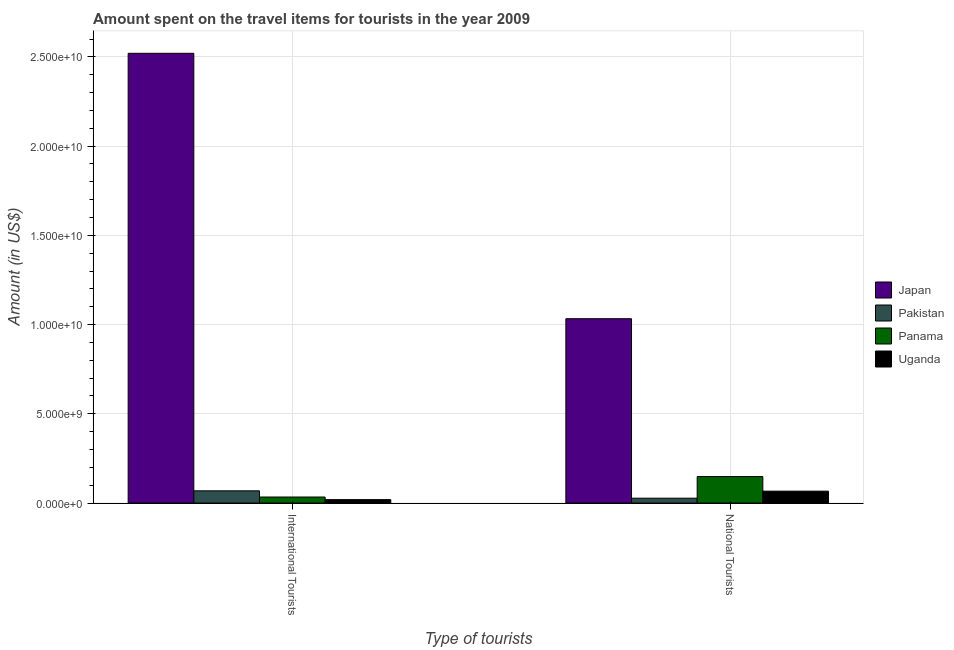How many different coloured bars are there?
Keep it short and to the point. 4. How many groups of bars are there?
Make the answer very short. 2. How many bars are there on the 1st tick from the right?
Your answer should be very brief. 4. What is the label of the 2nd group of bars from the left?
Your answer should be very brief. National Tourists. What is the amount spent on travel items of international tourists in Japan?
Ensure brevity in your answer.  2.52e+1. Across all countries, what is the maximum amount spent on travel items of international tourists?
Your answer should be very brief. 2.52e+1. Across all countries, what is the minimum amount spent on travel items of international tourists?
Provide a short and direct response. 1.92e+08. In which country was the amount spent on travel items of international tourists maximum?
Your answer should be compact. Japan. In which country was the amount spent on travel items of international tourists minimum?
Offer a very short reply. Uganda. What is the total amount spent on travel items of national tourists in the graph?
Ensure brevity in your answer.  1.28e+1. What is the difference between the amount spent on travel items of national tourists in Japan and that in Uganda?
Offer a very short reply. 9.66e+09. What is the difference between the amount spent on travel items of international tourists in Japan and the amount spent on travel items of national tourists in Pakistan?
Your answer should be compact. 2.49e+1. What is the average amount spent on travel items of national tourists per country?
Provide a succinct answer. 3.19e+09. What is the difference between the amount spent on travel items of national tourists and amount spent on travel items of international tourists in Uganda?
Your answer should be compact. 4.75e+08. What is the ratio of the amount spent on travel items of international tourists in Uganda to that in Japan?
Provide a succinct answer. 0.01. Is the amount spent on travel items of international tourists in Panama less than that in Pakistan?
Keep it short and to the point. Yes. In how many countries, is the amount spent on travel items of national tourists greater than the average amount spent on travel items of national tourists taken over all countries?
Your response must be concise. 1. What does the 2nd bar from the left in National Tourists represents?
Your answer should be very brief. Pakistan. What does the 4th bar from the right in National Tourists represents?
Ensure brevity in your answer.  Japan. Are all the bars in the graph horizontal?
Ensure brevity in your answer.  No. Does the graph contain grids?
Your answer should be compact. Yes. Where does the legend appear in the graph?
Give a very brief answer. Center right. How are the legend labels stacked?
Ensure brevity in your answer.  Vertical. What is the title of the graph?
Provide a short and direct response. Amount spent on the travel items for tourists in the year 2009. Does "Lao PDR" appear as one of the legend labels in the graph?
Your response must be concise. No. What is the label or title of the X-axis?
Ensure brevity in your answer.  Type of tourists. What is the Amount (in US$) in Japan in International Tourists?
Keep it short and to the point. 2.52e+1. What is the Amount (in US$) of Pakistan in International Tourists?
Ensure brevity in your answer.  6.85e+08. What is the Amount (in US$) in Panama in International Tourists?
Your answer should be compact. 3.38e+08. What is the Amount (in US$) in Uganda in International Tourists?
Give a very brief answer. 1.92e+08. What is the Amount (in US$) in Japan in National Tourists?
Your answer should be very brief. 1.03e+1. What is the Amount (in US$) in Pakistan in National Tourists?
Make the answer very short. 2.72e+08. What is the Amount (in US$) in Panama in National Tourists?
Give a very brief answer. 1.48e+09. What is the Amount (in US$) in Uganda in National Tourists?
Give a very brief answer. 6.67e+08. Across all Type of tourists, what is the maximum Amount (in US$) of Japan?
Your answer should be compact. 2.52e+1. Across all Type of tourists, what is the maximum Amount (in US$) of Pakistan?
Your answer should be compact. 6.85e+08. Across all Type of tourists, what is the maximum Amount (in US$) in Panama?
Provide a short and direct response. 1.48e+09. Across all Type of tourists, what is the maximum Amount (in US$) in Uganda?
Offer a terse response. 6.67e+08. Across all Type of tourists, what is the minimum Amount (in US$) of Japan?
Give a very brief answer. 1.03e+1. Across all Type of tourists, what is the minimum Amount (in US$) of Pakistan?
Keep it short and to the point. 2.72e+08. Across all Type of tourists, what is the minimum Amount (in US$) in Panama?
Give a very brief answer. 3.38e+08. Across all Type of tourists, what is the minimum Amount (in US$) in Uganda?
Give a very brief answer. 1.92e+08. What is the total Amount (in US$) of Japan in the graph?
Keep it short and to the point. 3.55e+1. What is the total Amount (in US$) in Pakistan in the graph?
Your response must be concise. 9.57e+08. What is the total Amount (in US$) in Panama in the graph?
Give a very brief answer. 1.82e+09. What is the total Amount (in US$) in Uganda in the graph?
Provide a succinct answer. 8.59e+08. What is the difference between the Amount (in US$) in Japan in International Tourists and that in National Tourists?
Provide a short and direct response. 1.49e+1. What is the difference between the Amount (in US$) in Pakistan in International Tourists and that in National Tourists?
Provide a short and direct response. 4.13e+08. What is the difference between the Amount (in US$) of Panama in International Tourists and that in National Tourists?
Your answer should be compact. -1.15e+09. What is the difference between the Amount (in US$) in Uganda in International Tourists and that in National Tourists?
Provide a short and direct response. -4.75e+08. What is the difference between the Amount (in US$) of Japan in International Tourists and the Amount (in US$) of Pakistan in National Tourists?
Your answer should be compact. 2.49e+1. What is the difference between the Amount (in US$) in Japan in International Tourists and the Amount (in US$) in Panama in National Tourists?
Keep it short and to the point. 2.37e+1. What is the difference between the Amount (in US$) of Japan in International Tourists and the Amount (in US$) of Uganda in National Tourists?
Your answer should be compact. 2.45e+1. What is the difference between the Amount (in US$) of Pakistan in International Tourists and the Amount (in US$) of Panama in National Tourists?
Give a very brief answer. -7.99e+08. What is the difference between the Amount (in US$) of Pakistan in International Tourists and the Amount (in US$) of Uganda in National Tourists?
Keep it short and to the point. 1.80e+07. What is the difference between the Amount (in US$) of Panama in International Tourists and the Amount (in US$) of Uganda in National Tourists?
Keep it short and to the point. -3.29e+08. What is the average Amount (in US$) of Japan per Type of tourists?
Your answer should be very brief. 1.78e+1. What is the average Amount (in US$) of Pakistan per Type of tourists?
Ensure brevity in your answer.  4.78e+08. What is the average Amount (in US$) in Panama per Type of tourists?
Your answer should be compact. 9.11e+08. What is the average Amount (in US$) in Uganda per Type of tourists?
Ensure brevity in your answer.  4.30e+08. What is the difference between the Amount (in US$) in Japan and Amount (in US$) in Pakistan in International Tourists?
Offer a terse response. 2.45e+1. What is the difference between the Amount (in US$) of Japan and Amount (in US$) of Panama in International Tourists?
Offer a very short reply. 2.49e+1. What is the difference between the Amount (in US$) of Japan and Amount (in US$) of Uganda in International Tourists?
Keep it short and to the point. 2.50e+1. What is the difference between the Amount (in US$) of Pakistan and Amount (in US$) of Panama in International Tourists?
Make the answer very short. 3.47e+08. What is the difference between the Amount (in US$) in Pakistan and Amount (in US$) in Uganda in International Tourists?
Provide a short and direct response. 4.93e+08. What is the difference between the Amount (in US$) in Panama and Amount (in US$) in Uganda in International Tourists?
Ensure brevity in your answer.  1.46e+08. What is the difference between the Amount (in US$) in Japan and Amount (in US$) in Pakistan in National Tourists?
Keep it short and to the point. 1.01e+1. What is the difference between the Amount (in US$) in Japan and Amount (in US$) in Panama in National Tourists?
Your answer should be very brief. 8.84e+09. What is the difference between the Amount (in US$) of Japan and Amount (in US$) of Uganda in National Tourists?
Make the answer very short. 9.66e+09. What is the difference between the Amount (in US$) in Pakistan and Amount (in US$) in Panama in National Tourists?
Ensure brevity in your answer.  -1.21e+09. What is the difference between the Amount (in US$) of Pakistan and Amount (in US$) of Uganda in National Tourists?
Offer a very short reply. -3.95e+08. What is the difference between the Amount (in US$) in Panama and Amount (in US$) in Uganda in National Tourists?
Offer a very short reply. 8.17e+08. What is the ratio of the Amount (in US$) in Japan in International Tourists to that in National Tourists?
Provide a short and direct response. 2.44. What is the ratio of the Amount (in US$) in Pakistan in International Tourists to that in National Tourists?
Offer a terse response. 2.52. What is the ratio of the Amount (in US$) in Panama in International Tourists to that in National Tourists?
Provide a short and direct response. 0.23. What is the ratio of the Amount (in US$) of Uganda in International Tourists to that in National Tourists?
Your answer should be compact. 0.29. What is the difference between the highest and the second highest Amount (in US$) in Japan?
Your response must be concise. 1.49e+1. What is the difference between the highest and the second highest Amount (in US$) of Pakistan?
Ensure brevity in your answer.  4.13e+08. What is the difference between the highest and the second highest Amount (in US$) of Panama?
Your answer should be compact. 1.15e+09. What is the difference between the highest and the second highest Amount (in US$) in Uganda?
Ensure brevity in your answer.  4.75e+08. What is the difference between the highest and the lowest Amount (in US$) of Japan?
Offer a very short reply. 1.49e+1. What is the difference between the highest and the lowest Amount (in US$) in Pakistan?
Provide a short and direct response. 4.13e+08. What is the difference between the highest and the lowest Amount (in US$) in Panama?
Your answer should be compact. 1.15e+09. What is the difference between the highest and the lowest Amount (in US$) of Uganda?
Your answer should be compact. 4.75e+08. 